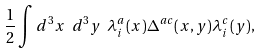<formula> <loc_0><loc_0><loc_500><loc_500>\frac { 1 } { 2 } \int d ^ { 3 } x \ d ^ { 3 } y \ \lambda _ { i } ^ { a } ( x ) \Delta ^ { a c } ( x , y ) \lambda _ { i } ^ { c } ( y ) ,</formula> 